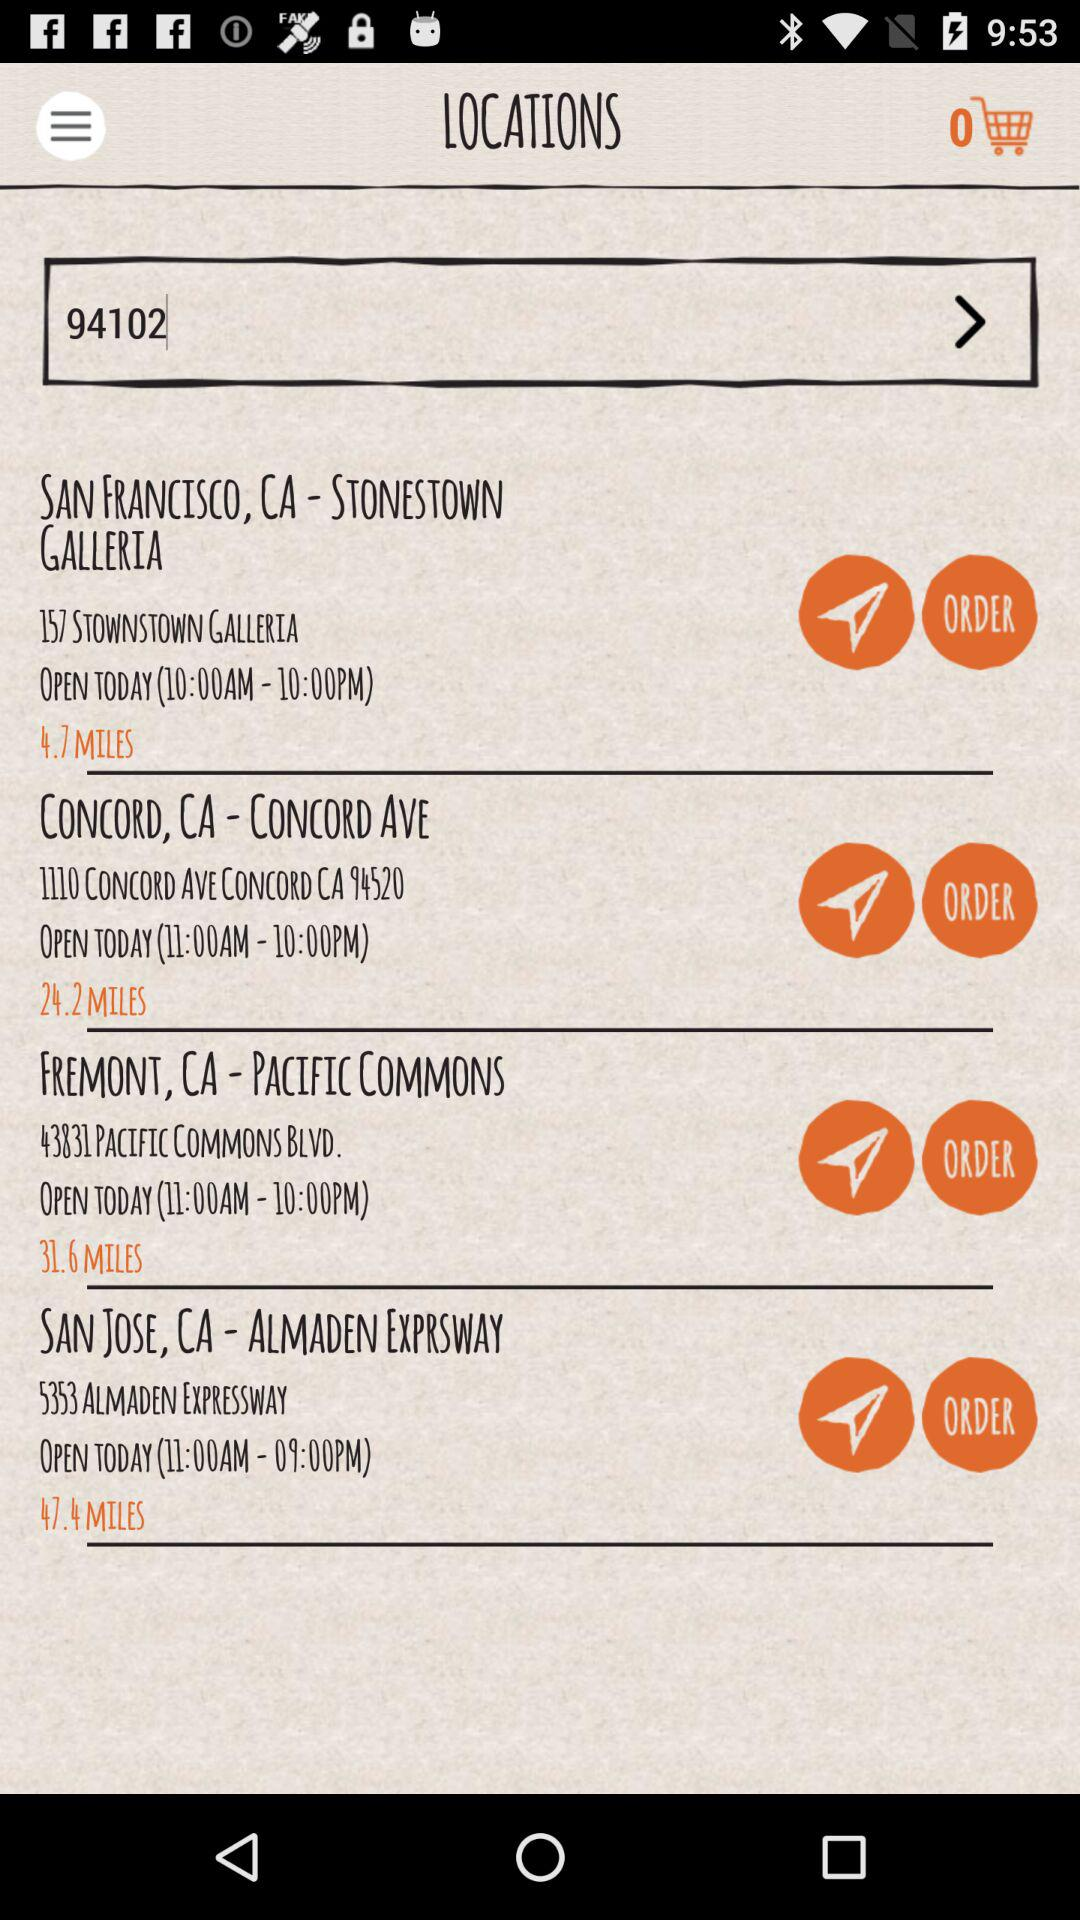How many stores are open today?
Answer the question using a single word or phrase. 4 